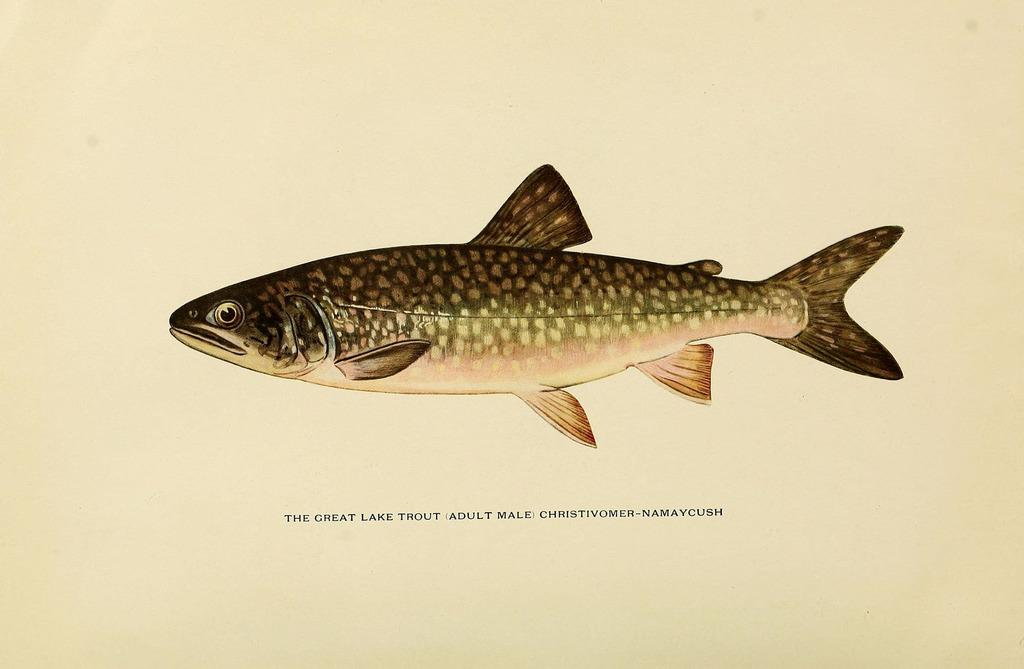What is depicted on the paper in the image? There is a print of a fish on a paper in the image. What else can be seen on the paper besides the fish print? There is text below the print of the fish. What type of alley can be seen in the background of the image? There is no alley present in the image; it only features a print of a fish on a paper with text below it. 